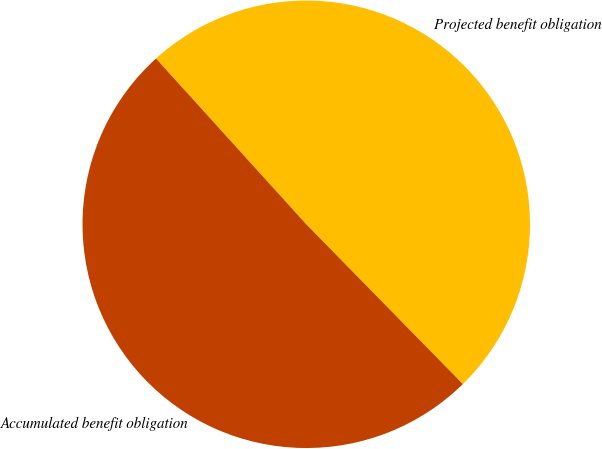Convert chart to OTSL. <chart><loc_0><loc_0><loc_500><loc_500><pie_chart><fcel>Projected benefit obligation<fcel>Accumulated benefit obligation<nl><fcel>49.38%<fcel>50.62%<nl></chart> 